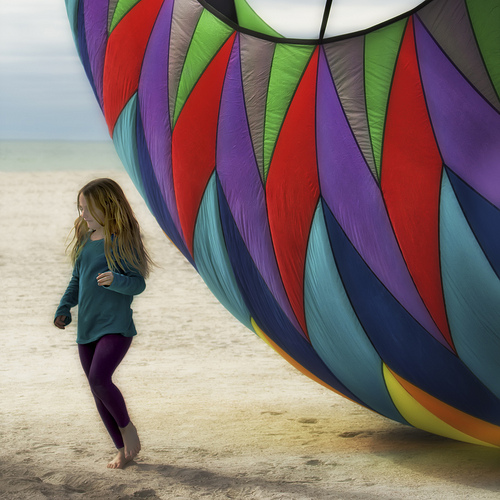<image>
Can you confirm if the sand is on the girl? No. The sand is not positioned on the girl. They may be near each other, but the sand is not supported by or resting on top of the girl. 